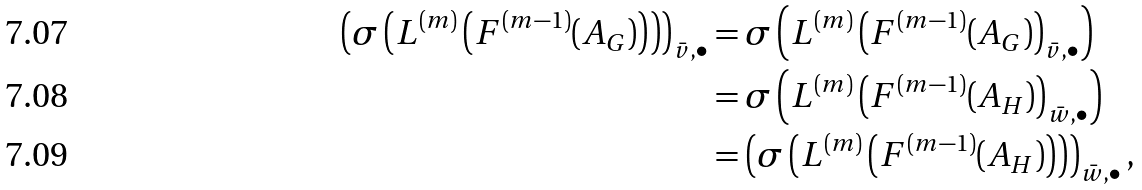<formula> <loc_0><loc_0><loc_500><loc_500>\left ( \sigma \left ( L ^ { ( m ) } \left ( F ^ { ( m - 1 ) } ( A _ { G } ) \right ) \right ) \right ) _ { \bar { v } , \bullet } & = \sigma \left ( L ^ { ( m ) } \left ( F ^ { ( m - 1 ) } ( A _ { G } ) \right ) _ { \bar { v } , \bullet } \right ) \\ & = \sigma \left ( L ^ { ( m ) } \left ( F ^ { ( m - 1 ) } ( A _ { H } ) \right ) _ { \bar { w } , \bullet } \right ) \\ & = \left ( \sigma \left ( L ^ { ( m ) } \left ( F ^ { ( m - 1 ) } ( A _ { H } ) \right ) \right ) \right ) _ { \bar { w } , \bullet } ,</formula> 